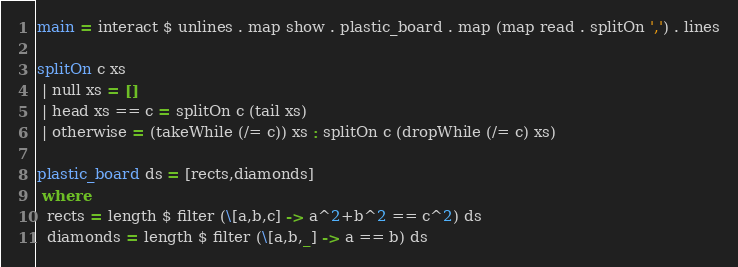Convert code to text. <code><loc_0><loc_0><loc_500><loc_500><_Haskell_>main = interact $ unlines . map show . plastic_board . map (map read . splitOn ',') . lines

splitOn c xs
 | null xs = []
 | head xs == c = splitOn c (tail xs)
 | otherwise = (takeWhile (/= c)) xs : splitOn c (dropWhile (/= c) xs)

plastic_board ds = [rects,diamonds]
 where
  rects = length $ filter (\[a,b,c] -> a^2+b^2 == c^2) ds
  diamonds = length $ filter (\[a,b,_] -> a == b) ds</code> 